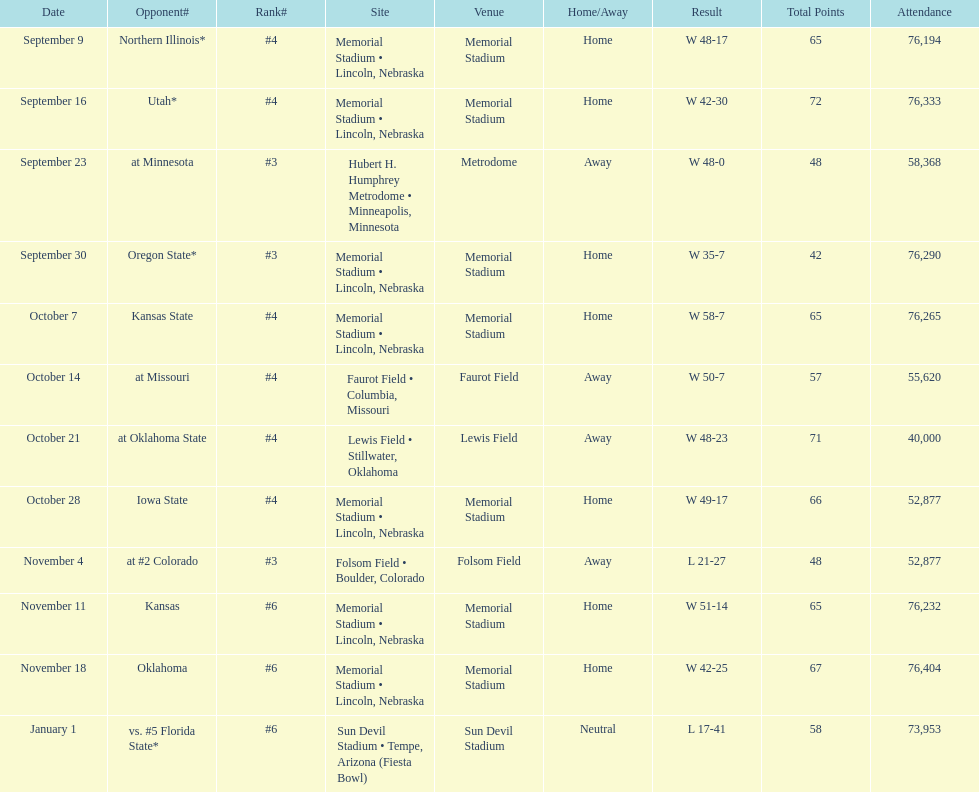What's the number of people who attended the oregon state game? 76,290. 